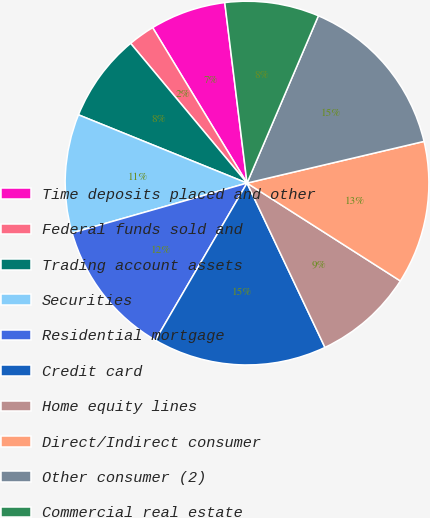Convert chart to OTSL. <chart><loc_0><loc_0><loc_500><loc_500><pie_chart><fcel>Time deposits placed and other<fcel>Federal funds sold and<fcel>Trading account assets<fcel>Securities<fcel>Residential mortgage<fcel>Credit card<fcel>Home equity lines<fcel>Direct/Indirect consumer<fcel>Other consumer (2)<fcel>Commercial real estate<nl><fcel>6.73%<fcel>2.37%<fcel>7.82%<fcel>10.54%<fcel>12.18%<fcel>15.45%<fcel>8.91%<fcel>12.72%<fcel>14.9%<fcel>8.37%<nl></chart> 